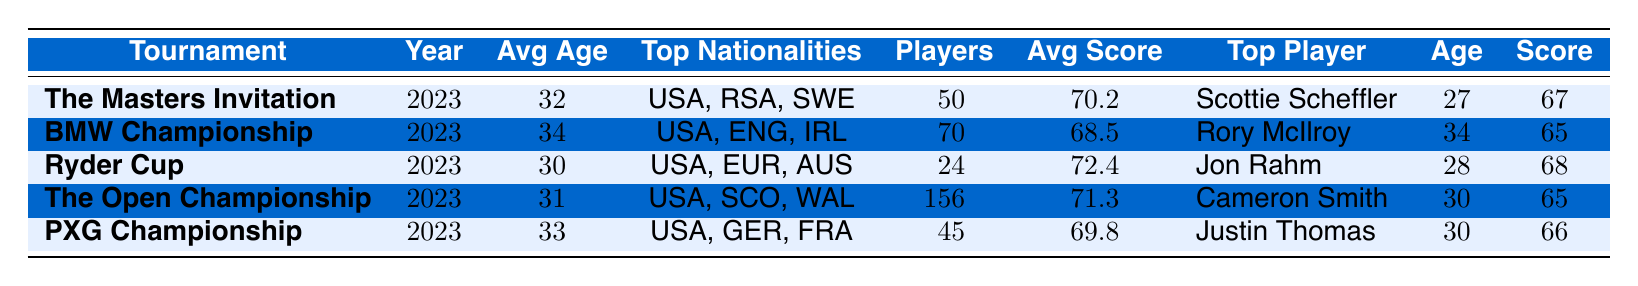What is the average age of players in The Masters Invitation? The table shows the average age of players in The Masters Invitation as 32 years old in the corresponding row.
Answer: 32 Who had the best score in the BMW Championship? The top player in the BMW Championship, as per the table, is Rory McIlroy with a score of 65.
Answer: Rory McIlroy How many players participated in The Open Championship? The number of players listed for The Open Championship in the table is 156.
Answer: 156 Which tournament had the highest average score? By comparing the average scores, The Ryder Cup has the highest average score of 72.4 in the table.
Answer: Ryder Cup What is the average age of players across all tournaments listed? To find the average age, sum the average ages of all tournaments: (32 + 34 + 30 + 31 + 33) = 160. Then divide by the number of tournaments (5): 160 / 5 = 32.
Answer: 32 Is the average score of the PXG Championship lower than that of The Open Championship? The average score for PXG Championship is 69.8 and for The Open Championship it is 71.3. Since 69.8 < 71.3, the statement is true.
Answer: Yes Which nationality is most common in The Masters Invitation? The table shows that the most common nationality among players in The Masters Invitation is USA since it is listed first in the top nationalities section.
Answer: USA How does the average age of players in the Ryder Cup compare to that in the BMW Championship? The average age in Ryder Cup is 30 and in BMW Championship is 34. Since 30 < 34, Ryder Cup has a younger average age.
Answer: Younger What is the average score difference between The Masters Invitation and the PXG Championship? The average score for The Masters Invitation is 70.2 and for PXG Championship it is 69.8. The difference is 70.2 - 69.8 = 0.4.
Answer: 0.4 What is the nationality of the top performing player in the PXG Championship? The table lists Justin Thomas as the top player in the PXG Championship and indicates his nationality as USA.
Answer: USA 